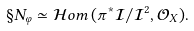<formula> <loc_0><loc_0><loc_500><loc_500>\S N _ { \varphi } \simeq \mathcal { H } o m \, ( \pi ^ { \ast } \mathcal { I } / \mathcal { I } ^ { 2 } , \mathcal { O } _ { X } ) .</formula> 